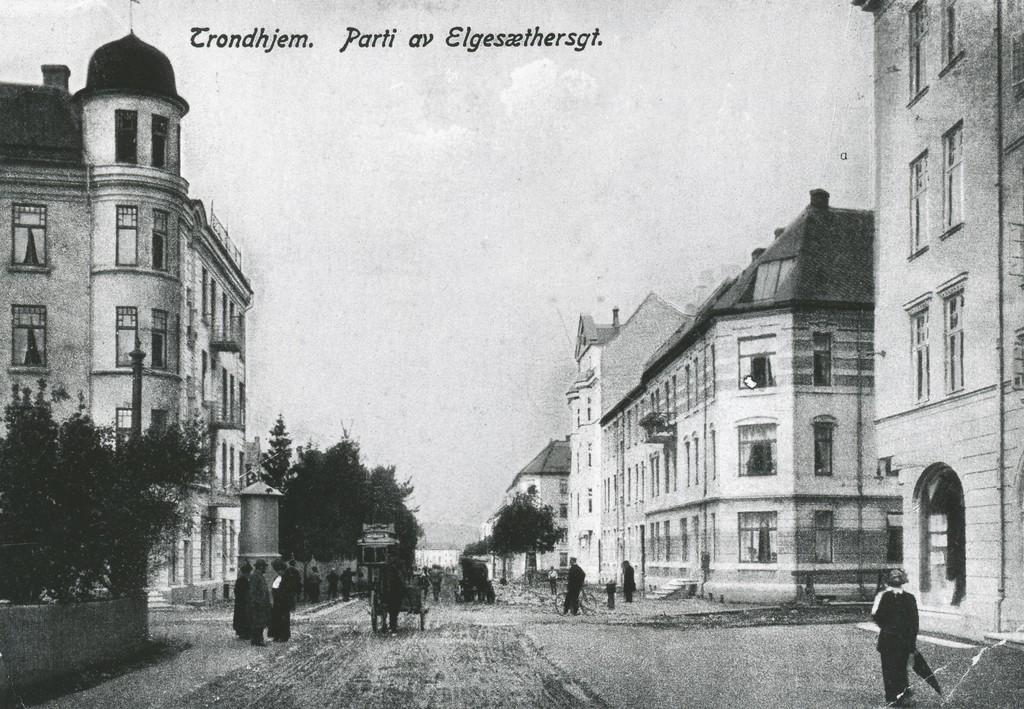How would you summarize this image in a sentence or two? This picture is in black and white. In between the building there is a road in the center. On the road there were people roaming around. At the bottom right there is a person holding an umbrella. Towards the bottom left there is a tree and a wall. On the top there is some text and a wall. 